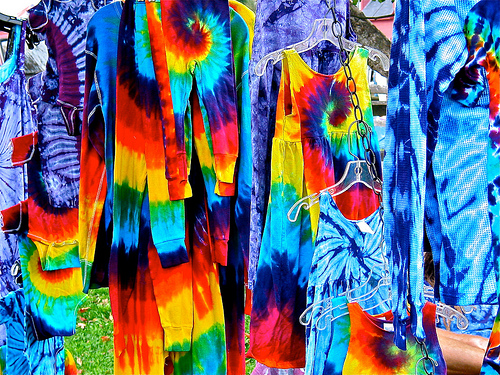<image>
Can you confirm if the yellow is behind the pant? No. The yellow is not behind the pant. From this viewpoint, the yellow appears to be positioned elsewhere in the scene. 